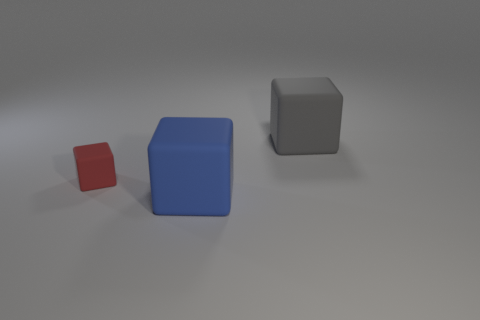Is there anything else that is the same size as the red thing?
Offer a terse response. No. Is the material of the thing behind the red thing the same as the tiny red object?
Offer a terse response. Yes. Are there the same number of matte things that are behind the big gray rubber thing and small rubber blocks that are behind the big blue matte cube?
Keep it short and to the point. No. How many red matte blocks are behind the big thing that is in front of the gray thing?
Offer a terse response. 1. There is a large matte object in front of the red cube; does it have the same color as the matte cube behind the tiny block?
Offer a very short reply. No. There is a object in front of the small matte object in front of the big cube that is right of the large blue rubber block; what is its shape?
Provide a short and direct response. Cube. What number of large cubes are behind the big matte thing that is in front of the cube that is behind the small object?
Keep it short and to the point. 1. Are there more small matte objects left of the gray block than large gray things in front of the small matte block?
Your answer should be compact. Yes. What number of other tiny red matte things are the same shape as the small red matte thing?
Your response must be concise. 0. What number of objects are either large matte objects right of the blue cube or large things behind the small red object?
Your response must be concise. 1. 